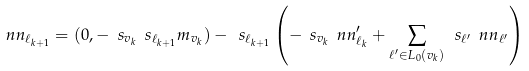Convert formula to latex. <formula><loc_0><loc_0><loc_500><loc_500>\ n n _ { \ell _ { k + 1 } } = ( 0 , - \ s _ { v _ { k } } \ s _ { \ell _ { k + 1 } } m _ { v _ { k } } ) - \ s _ { \ell _ { k + 1 } } \left ( - \ s _ { v _ { k } } \ n n _ { \ell _ { k } } ^ { \prime } + \sum _ { \ell ^ { \prime } \in L _ { 0 } ( v _ { k } ) } \ s _ { \ell ^ { \prime } } \ n n _ { \ell ^ { \prime } } \right )</formula> 